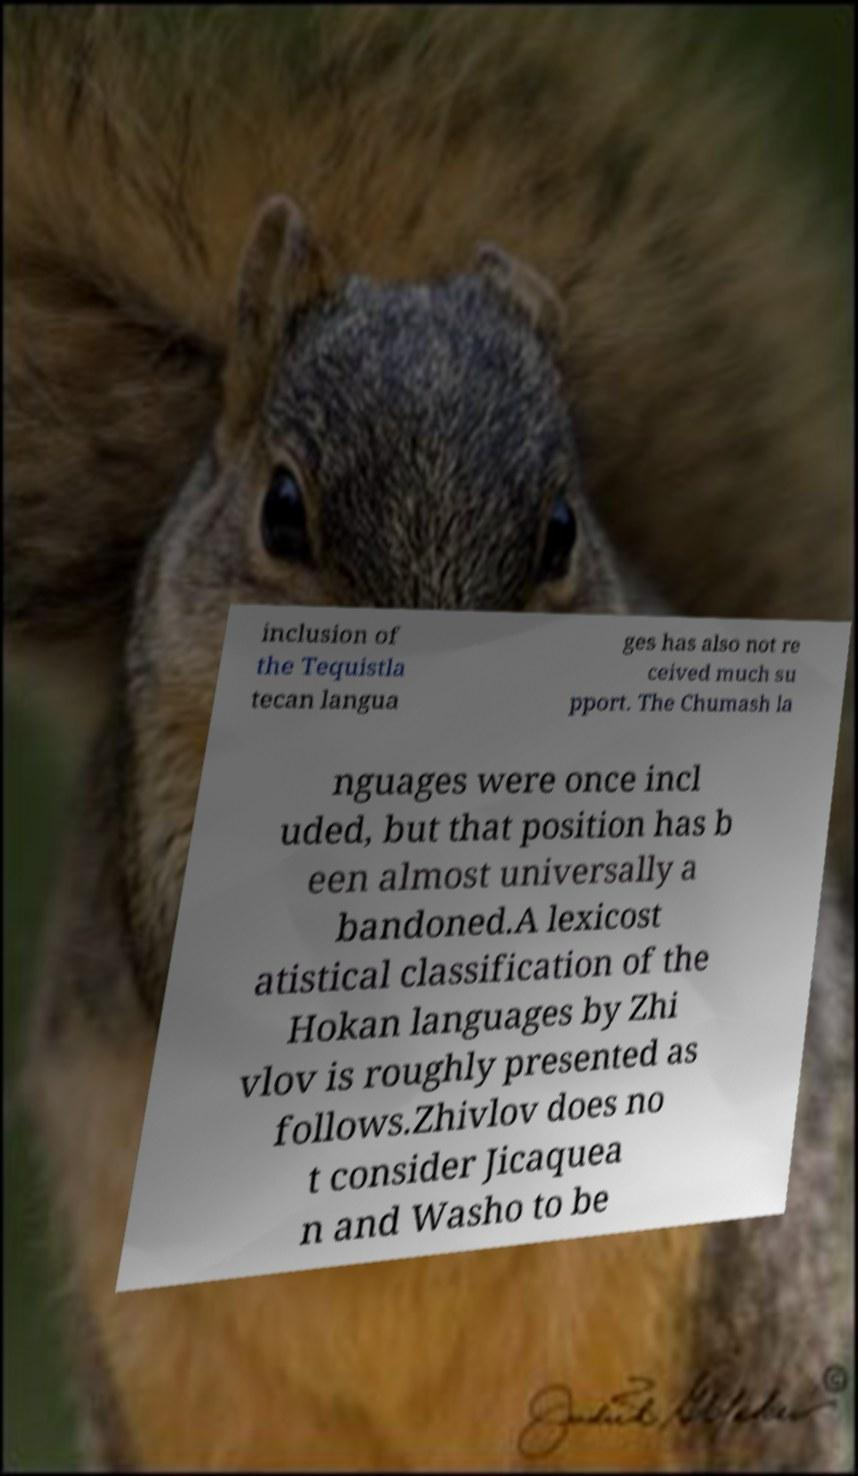There's text embedded in this image that I need extracted. Can you transcribe it verbatim? inclusion of the Tequistla tecan langua ges has also not re ceived much su pport. The Chumash la nguages were once incl uded, but that position has b een almost universally a bandoned.A lexicost atistical classification of the Hokan languages by Zhi vlov is roughly presented as follows.Zhivlov does no t consider Jicaquea n and Washo to be 